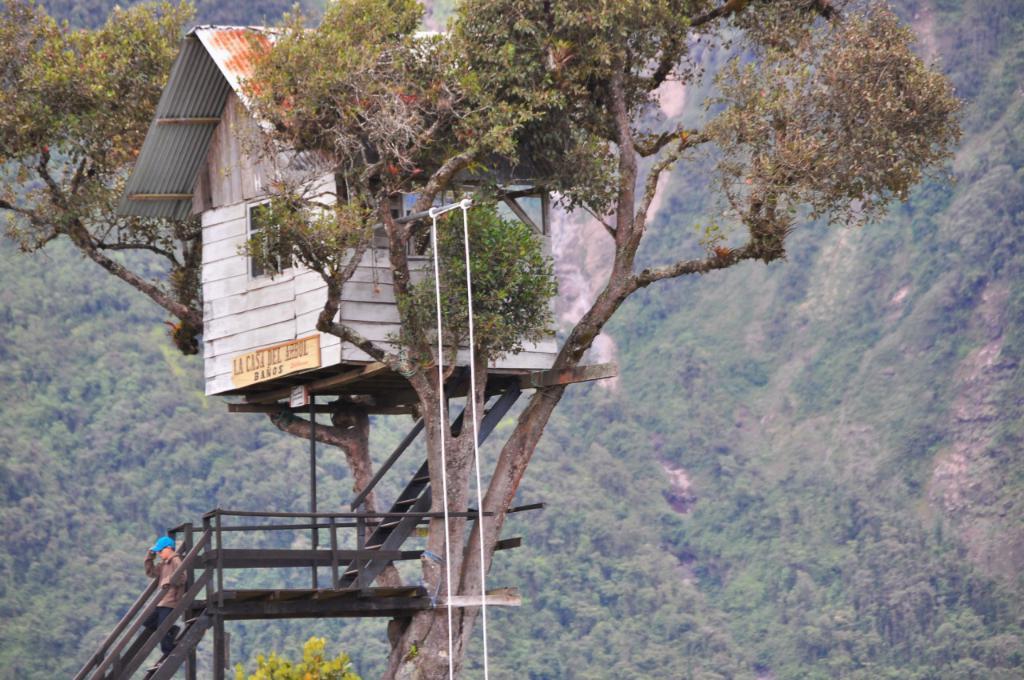Please provide a concise description of this image. In the image we can see there is a tree house and there are iron stairs attached to it. There is a kid standing on the stairs and behind there are hills. There are trees on the hills. 